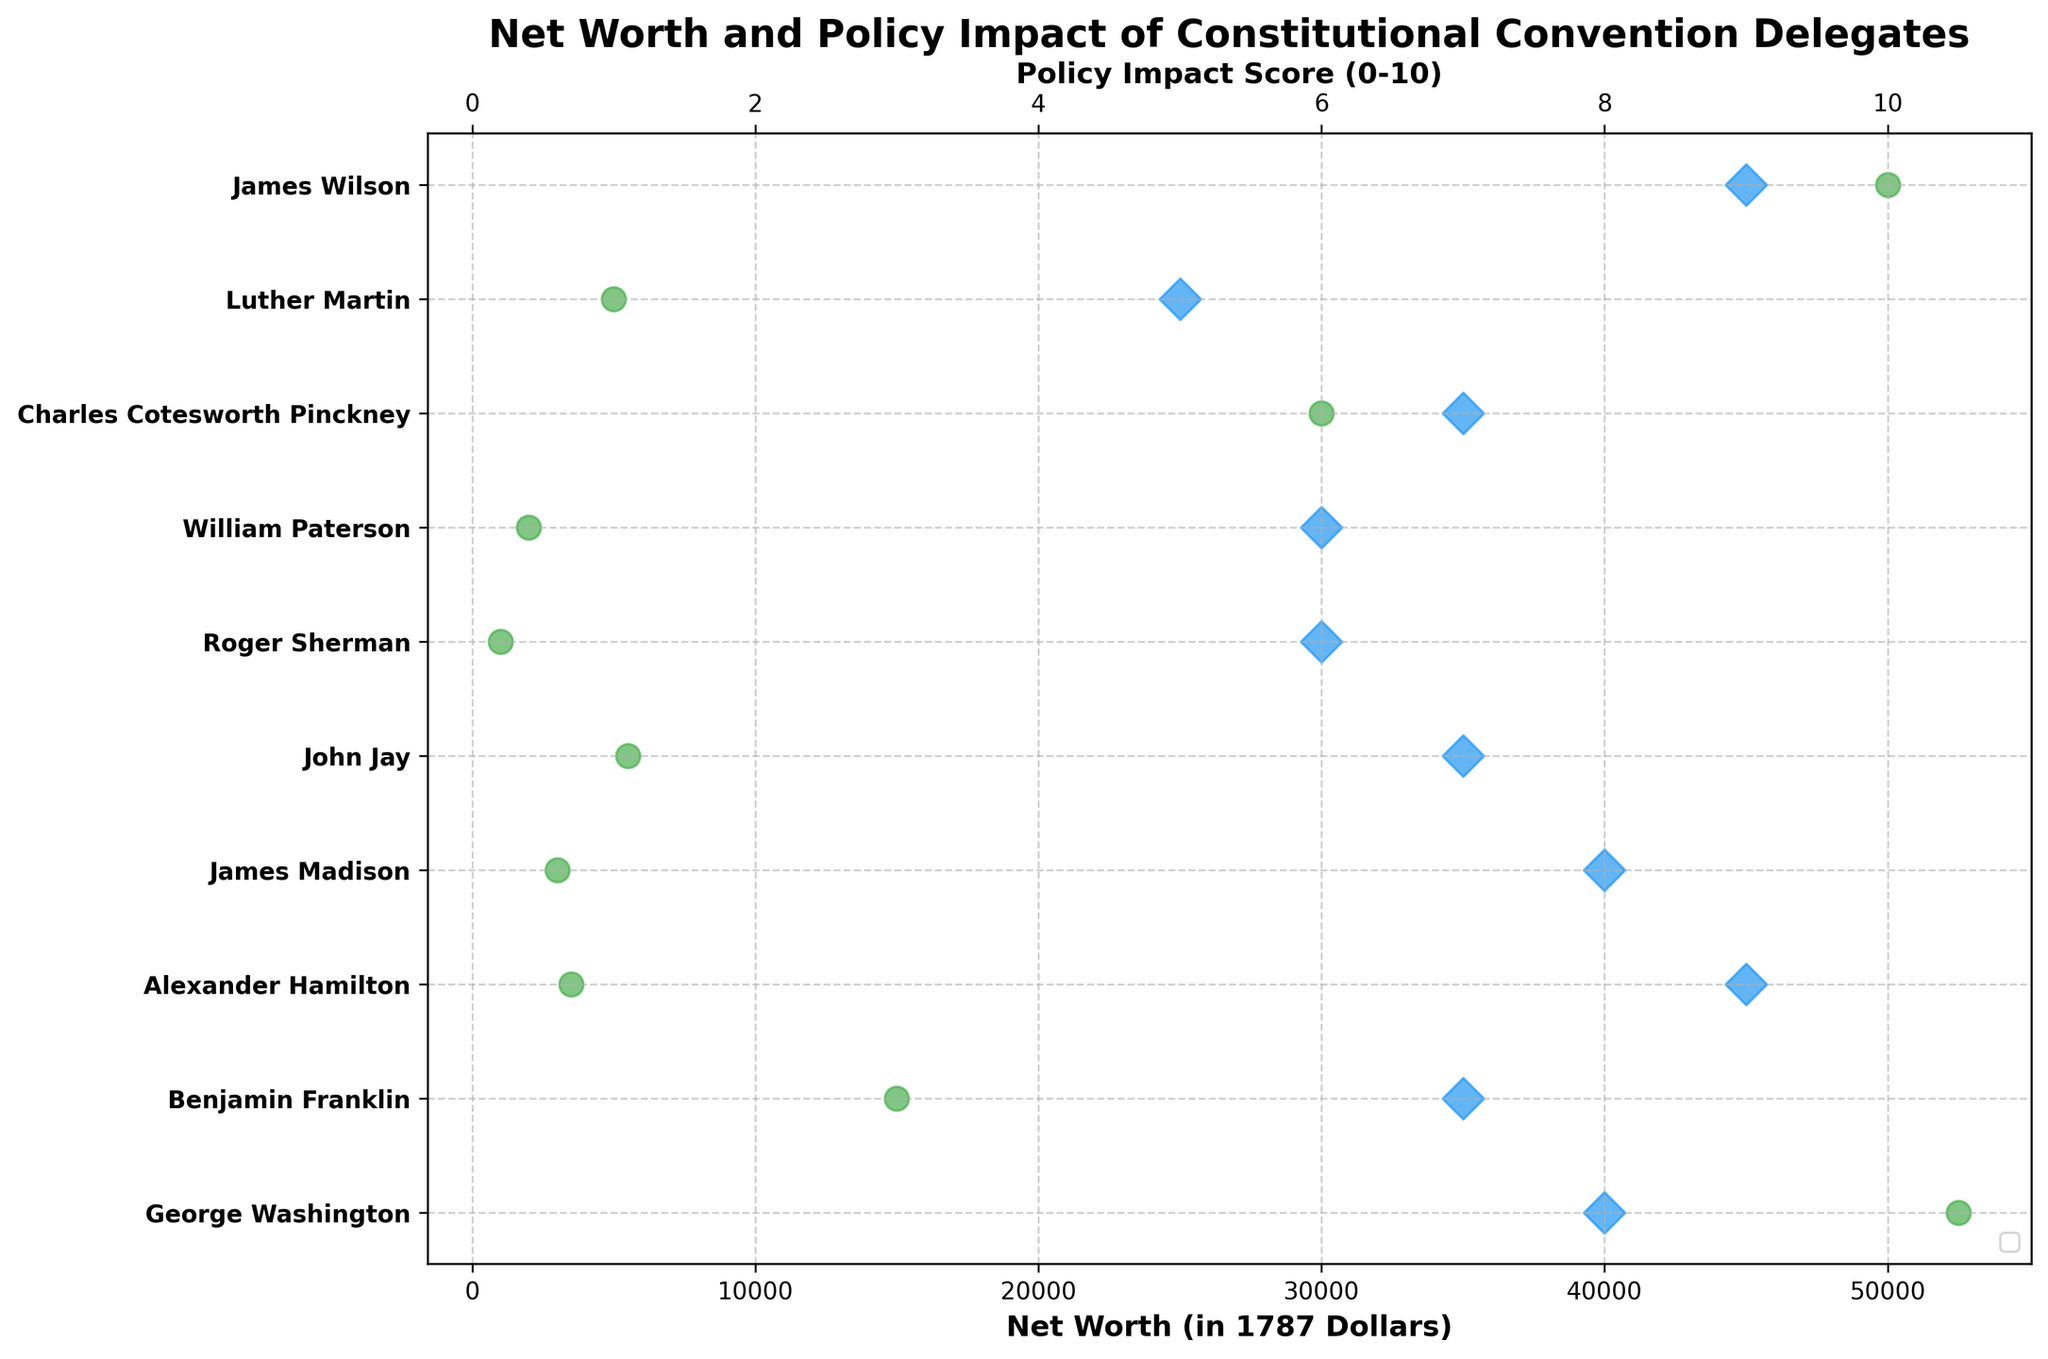What are the main colors used for the dot plots representing the delegates' net worth and policy impact scores? The plot uses two main colors: one for net worth and another for policy impact scores. The net worth dots are green, while the policy impact score dots are blue.
Answer: Green and blue Which delegate has the highest net worth among the Constitutional Convention delegates as shown in the figure? The figure shows that James Wilson's dot for net worth is the furthest to the right, indicating the highest net worth.
Answer: James Wilson How does George Washington's policy impact score compare to that of William Paterson? By looking at the figure, George Washington's impact score (represented by a blue diamond dot) is further to the right than William Paterson's, meaning it is higher. Specifically, Washington has an impact score of 8, while Paterson has 6.
Answer: Higher Arrange the delegates George Washington, Alexander Hamilton, and James Madison in order of increasing net worth. According to the figure, the positions of their green dots show that James Madison has the lowest net worth, followed by Alexander Hamilton, and George Washington has the highest.
Answer: James Madison, Alexander Hamilton, George Washington Which delegate has both a high net worth and a high policy impact score? From the figure, look for delegates whose green and blue dots are both positioned far to the right. James Wilson has high values for both metrics.
Answer: James Wilson What is the net worth difference between Charles Cotesworth Pinckney and Luther Martin? By checking the positions of the green dots for both delegates, Charles Cotesworth Pinckney’s net worth is $30,000 and Luther Martin’s is $5,000. The difference is $30,000 - $5,000 = $25,000.
Answer: $25,000 Which delegate's net worth and impact score dots are closest together in the figure? Looking at the plot, Roger Sherman's net worth and policy impact score dots are positioned closest together horizontally.
Answer: Roger Sherman What does a secondary x-axis in the figure represent, and how is it formatted? The secondary x-axis at the top of the figure represents the policy impact score, which ranges from 0 to 10 and is formatted in increments of 2. This axis helps approximate the policy impact score more precisely.
Answer: Policy impact score ranging from 0 to 10 Compare the net worths of the delegates who pursued education from Princeton University. In the figure, James Madison ($3,000) and William Paterson ($2,000) are the delegates who attended Princeton. Madison’s net worth is higher than Paterson’s.
Answer: James Madison has a higher net worth than William Paterson 